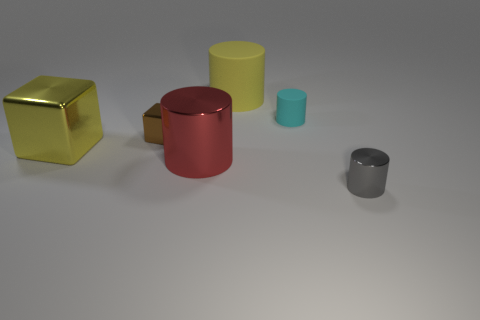Subtract all cyan rubber cylinders. How many cylinders are left? 3 Add 2 small green things. How many objects exist? 8 Subtract 1 blocks. How many blocks are left? 1 Subtract all brown cubes. How many cubes are left? 1 Subtract 1 yellow blocks. How many objects are left? 5 Subtract all cylinders. How many objects are left? 2 Subtract all brown cubes. Subtract all cyan balls. How many cubes are left? 1 Subtract all small metallic cylinders. Subtract all small red metallic cylinders. How many objects are left? 5 Add 5 tiny shiny things. How many tiny shiny things are left? 7 Add 4 large yellow matte things. How many large yellow matte things exist? 5 